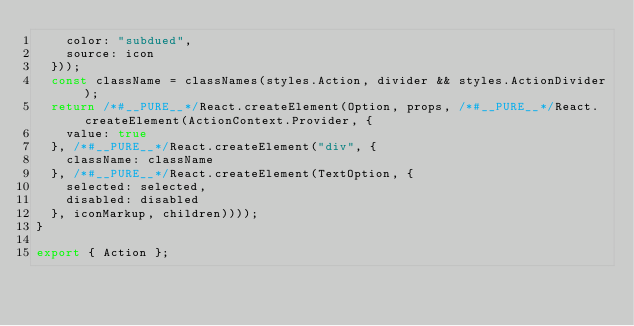<code> <loc_0><loc_0><loc_500><loc_500><_JavaScript_>    color: "subdued",
    source: icon
  }));
  const className = classNames(styles.Action, divider && styles.ActionDivider);
  return /*#__PURE__*/React.createElement(Option, props, /*#__PURE__*/React.createElement(ActionContext.Provider, {
    value: true
  }, /*#__PURE__*/React.createElement("div", {
    className: className
  }, /*#__PURE__*/React.createElement(TextOption, {
    selected: selected,
    disabled: disabled
  }, iconMarkup, children))));
}

export { Action };
</code> 